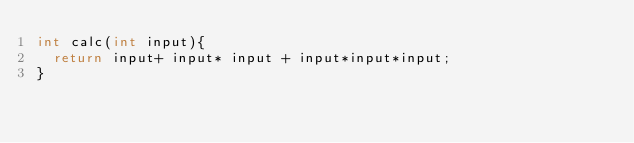<code> <loc_0><loc_0><loc_500><loc_500><_Java_>int calc(int input){
  return input+ input* input + input*input*input;
}</code> 